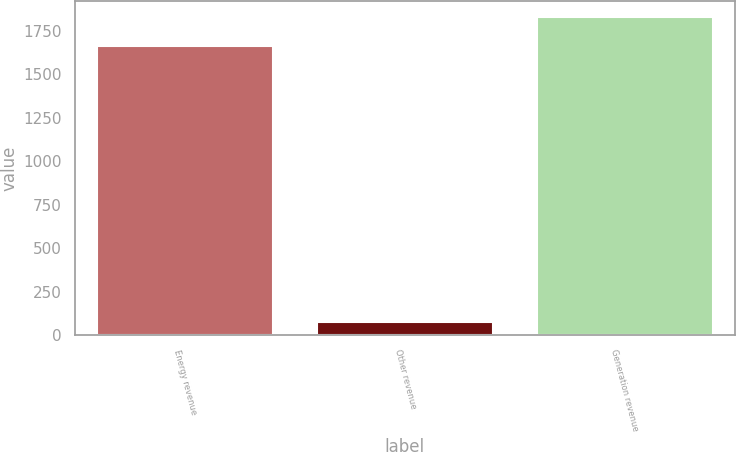Convert chart to OTSL. <chart><loc_0><loc_0><loc_500><loc_500><bar_chart><fcel>Energy revenue<fcel>Other revenue<fcel>Generation revenue<nl><fcel>1662<fcel>79<fcel>1832<nl></chart> 